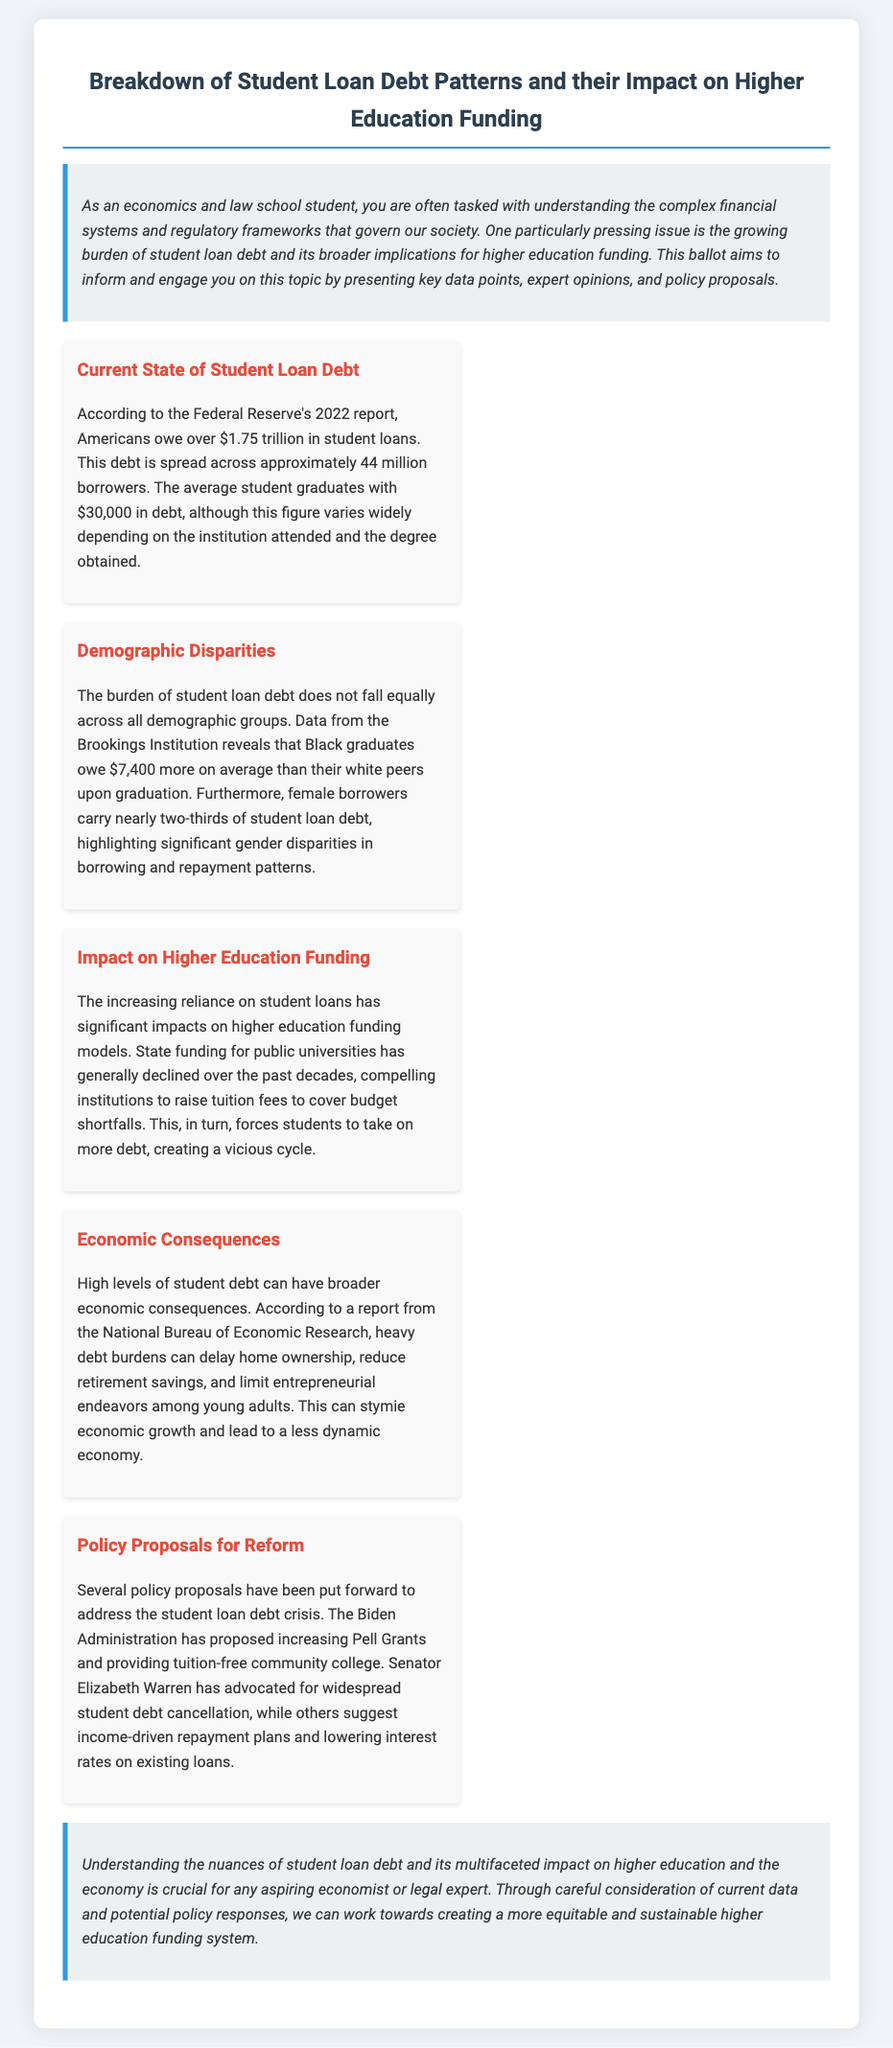What is the total student loan debt in the U.S.? According to the Federal Reserve's 2022 report, Americans owe over $1.75 trillion in student loans.
Answer: $1.75 trillion How many borrowers are affected by student loan debt? The document states that this debt is spread across approximately 44 million borrowers.
Answer: 44 million What is the average student loan debt at graduation? The average student graduates with $30,000 in debt, as mentioned in the document.
Answer: $30,000 Who owes more on average, Black graduates or white graduates? Data from the Brookings Institution reveals that Black graduates owe $7,400 more on average than their white peers upon graduation.
Answer: $7,400 What is a proposed policy to address student debt? The Biden Administration has proposed increasing Pell Grants as one of the policy responses.
Answer: Increasing Pell Grants What is one economic consequence of high student debt? According to the National Bureau of Economic Research, heavy debt burdens can delay home ownership among young adults.
Answer: Delay home ownership What demographic group carries nearly two-thirds of student loan debt? The document states that female borrowers carry nearly two-thirds of student loan debt.
Answer: Female borrowers Why have public university tuition fees generally increased? The text indicates that declining state funding for public universities has compelled institutions to raise tuition fees.
Answer: Declining state funding What type of document is presented? The document is classified as a ballot on student loan debt patterns and their impact on higher education funding.
Answer: Ballot 